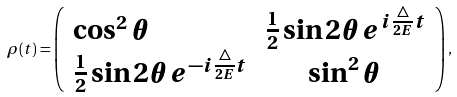Convert formula to latex. <formula><loc_0><loc_0><loc_500><loc_500>\rho ( t ) = \left ( \begin{array} { l c r } \cos ^ { 2 } \theta & \frac { 1 } { 2 } \sin 2 \theta e ^ { i \frac { \triangle } { 2 E } t } \\ \frac { 1 } { 2 } \sin 2 \theta e ^ { - i \frac { \triangle } { 2 E } t } & \sin ^ { 2 } \theta \end{array} \right ) ,</formula> 